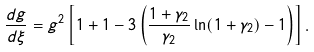<formula> <loc_0><loc_0><loc_500><loc_500>\frac { d g } { d \xi } = g ^ { 2 } \left [ 1 + 1 - 3 \left ( \frac { 1 + \gamma _ { 2 } } { \gamma _ { 2 } } \ln ( 1 + \gamma _ { 2 } ) - 1 \right ) \right ] .</formula> 